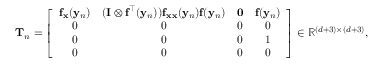Convert formula to latex. <formula><loc_0><loc_0><loc_500><loc_500>T _ { n } = \left [ { \begin{array} { c c c c } { f _ { x } ( y _ { n } ) } & { ( I \otimes f ^ { \intercal } ( y _ { n } ) ) f _ { x x } ( y _ { n } ) f ( y _ { n } ) } & { 0 } & { f ( y _ { n } ) } \\ { 0 } & { 0 } & { 0 } & { 0 } \\ { 0 } & { 0 } & { 0 } & { 1 } \\ { 0 } & { 0 } & { 0 } & { 0 } \end{array} } \right ] \in \mathbb { R } ^ { ( d + 3 ) \times ( d + 3 ) } ,</formula> 